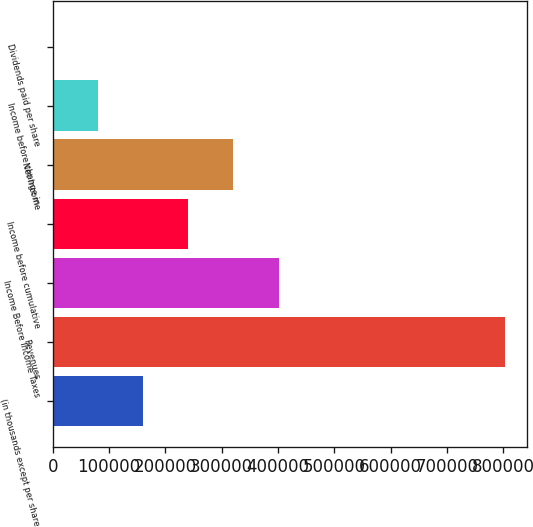Convert chart to OTSL. <chart><loc_0><loc_0><loc_500><loc_500><bar_chart><fcel>(in thousands except per share<fcel>Revenues<fcel>Income Before Income Taxes<fcel>Income before cumulative<fcel>Net Income<fcel>Income before change in<fcel>Dividends paid per share<nl><fcel>160484<fcel>802417<fcel>401209<fcel>240725<fcel>320967<fcel>80241.9<fcel>0.2<nl></chart> 